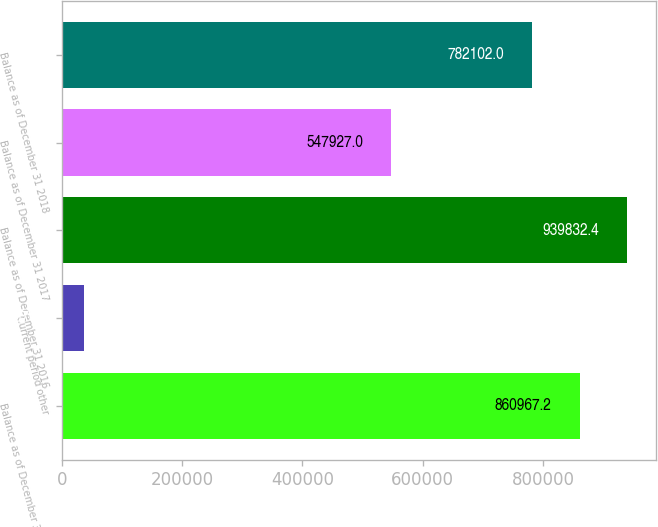<chart> <loc_0><loc_0><loc_500><loc_500><bar_chart><fcel>Balance as of December 31 2015<fcel>Current period other<fcel>Balance as of December 31 2016<fcel>Balance as of December 31 2017<fcel>Balance as of December 31 2018<nl><fcel>860967<fcel>36702<fcel>939832<fcel>547927<fcel>782102<nl></chart> 